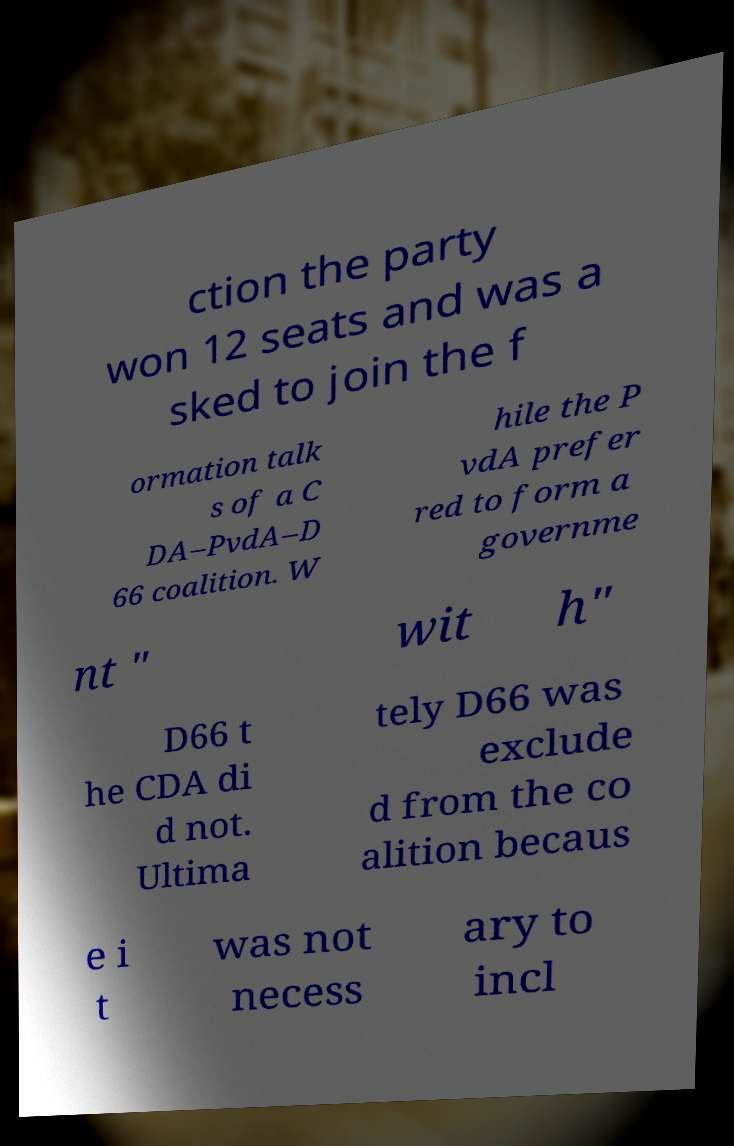Could you assist in decoding the text presented in this image and type it out clearly? ction the party won 12 seats and was a sked to join the f ormation talk s of a C DA–PvdA–D 66 coalition. W hile the P vdA prefer red to form a governme nt " wit h" D66 t he CDA di d not. Ultima tely D66 was exclude d from the co alition becaus e i t was not necess ary to incl 